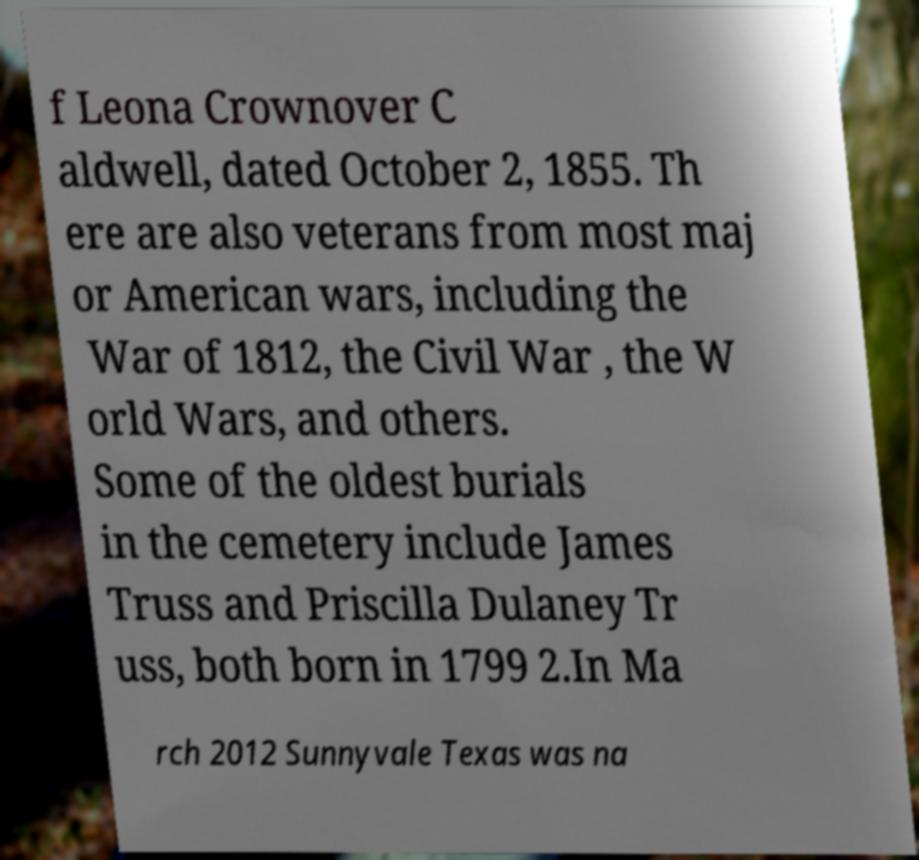For documentation purposes, I need the text within this image transcribed. Could you provide that? f Leona Crownover C aldwell, dated October 2, 1855. Th ere are also veterans from most maj or American wars, including the War of 1812, the Civil War , the W orld Wars, and others. Some of the oldest burials in the cemetery include James Truss and Priscilla Dulaney Tr uss, both born in 1799 2.In Ma rch 2012 Sunnyvale Texas was na 